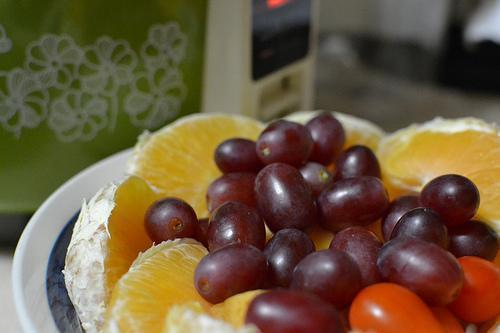How many fruits are there?
Give a very brief answer. 3. How many plates are there?
Give a very brief answer. 1. 